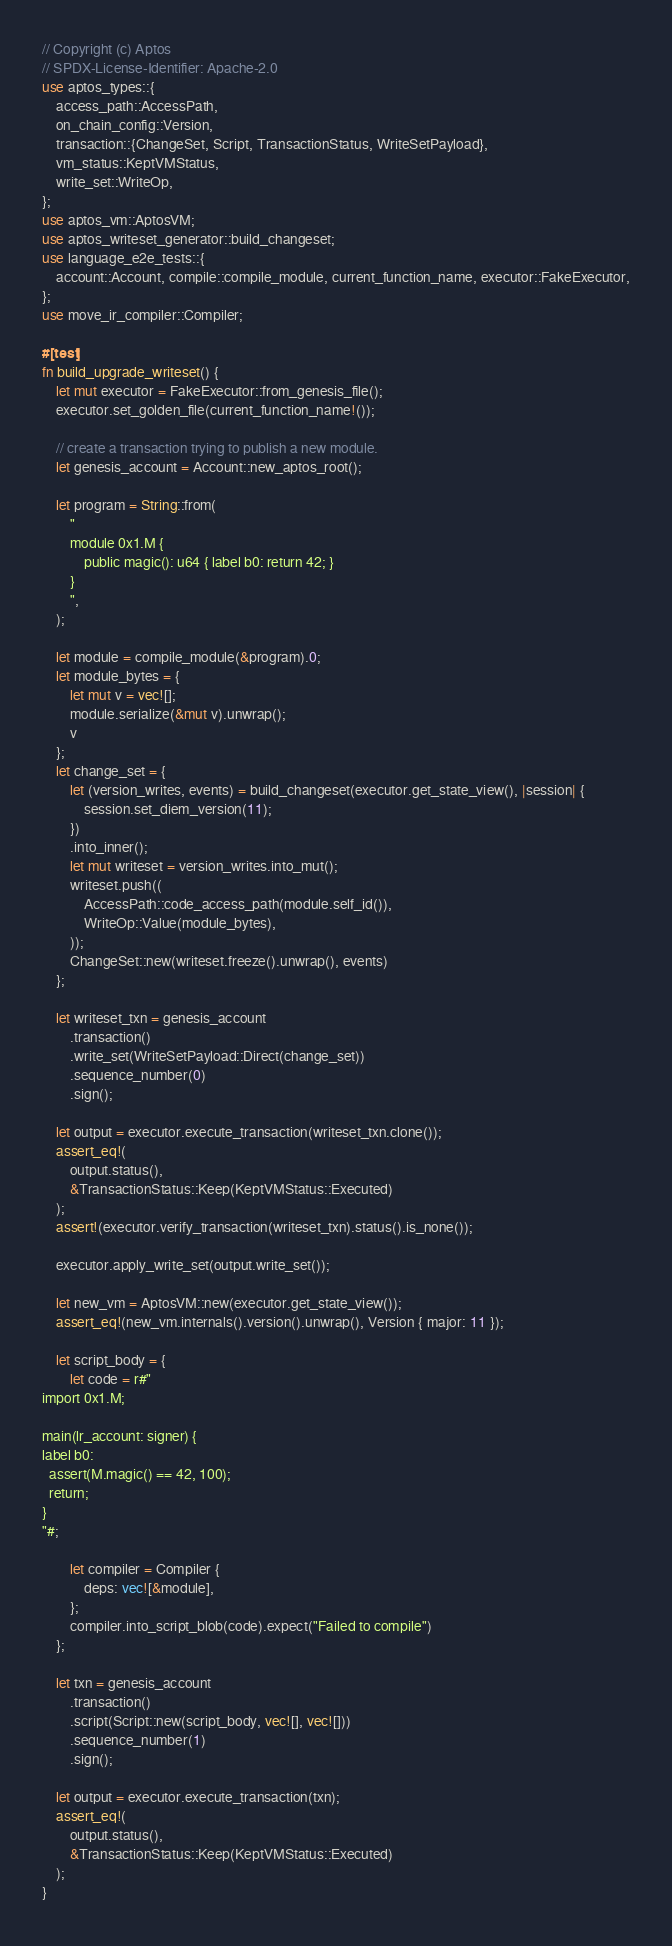<code> <loc_0><loc_0><loc_500><loc_500><_Rust_>// Copyright (c) Aptos
// SPDX-License-Identifier: Apache-2.0
use aptos_types::{
    access_path::AccessPath,
    on_chain_config::Version,
    transaction::{ChangeSet, Script, TransactionStatus, WriteSetPayload},
    vm_status::KeptVMStatus,
    write_set::WriteOp,
};
use aptos_vm::AptosVM;
use aptos_writeset_generator::build_changeset;
use language_e2e_tests::{
    account::Account, compile::compile_module, current_function_name, executor::FakeExecutor,
};
use move_ir_compiler::Compiler;

#[test]
fn build_upgrade_writeset() {
    let mut executor = FakeExecutor::from_genesis_file();
    executor.set_golden_file(current_function_name!());

    // create a transaction trying to publish a new module.
    let genesis_account = Account::new_aptos_root();

    let program = String::from(
        "
        module 0x1.M {
            public magic(): u64 { label b0: return 42; }
        }
        ",
    );

    let module = compile_module(&program).0;
    let module_bytes = {
        let mut v = vec![];
        module.serialize(&mut v).unwrap();
        v
    };
    let change_set = {
        let (version_writes, events) = build_changeset(executor.get_state_view(), |session| {
            session.set_diem_version(11);
        })
        .into_inner();
        let mut writeset = version_writes.into_mut();
        writeset.push((
            AccessPath::code_access_path(module.self_id()),
            WriteOp::Value(module_bytes),
        ));
        ChangeSet::new(writeset.freeze().unwrap(), events)
    };

    let writeset_txn = genesis_account
        .transaction()
        .write_set(WriteSetPayload::Direct(change_set))
        .sequence_number(0)
        .sign();

    let output = executor.execute_transaction(writeset_txn.clone());
    assert_eq!(
        output.status(),
        &TransactionStatus::Keep(KeptVMStatus::Executed)
    );
    assert!(executor.verify_transaction(writeset_txn).status().is_none());

    executor.apply_write_set(output.write_set());

    let new_vm = AptosVM::new(executor.get_state_view());
    assert_eq!(new_vm.internals().version().unwrap(), Version { major: 11 });

    let script_body = {
        let code = r#"
import 0x1.M;

main(lr_account: signer) {
label b0:
  assert(M.magic() == 42, 100);
  return;
}
"#;

        let compiler = Compiler {
            deps: vec![&module],
        };
        compiler.into_script_blob(code).expect("Failed to compile")
    };

    let txn = genesis_account
        .transaction()
        .script(Script::new(script_body, vec![], vec![]))
        .sequence_number(1)
        .sign();

    let output = executor.execute_transaction(txn);
    assert_eq!(
        output.status(),
        &TransactionStatus::Keep(KeptVMStatus::Executed)
    );
}
</code> 